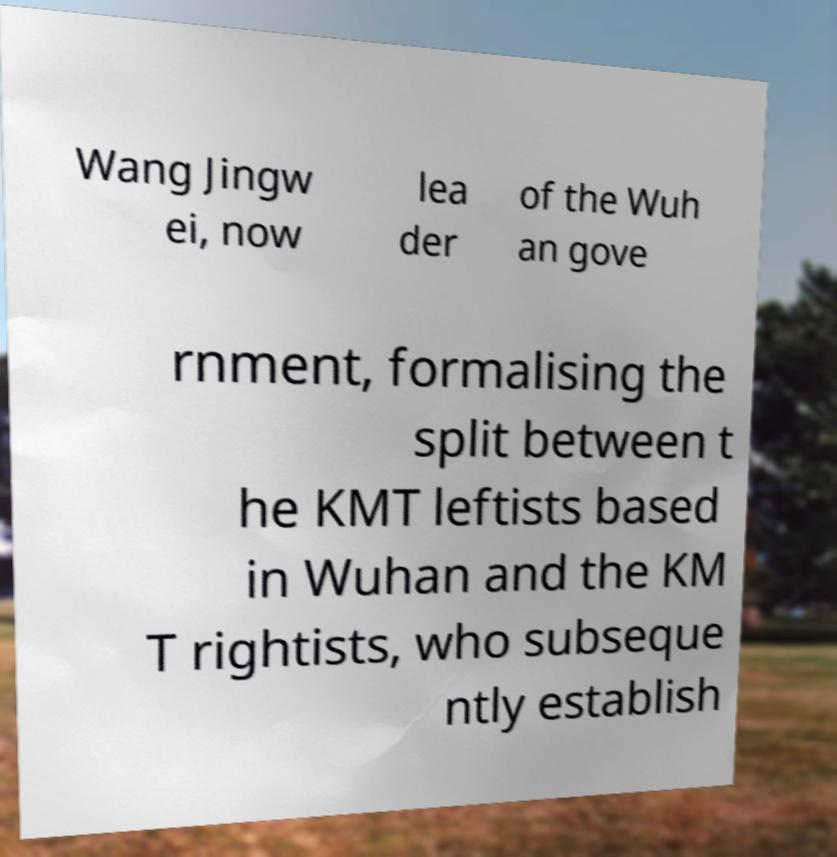What messages or text are displayed in this image? I need them in a readable, typed format. Wang Jingw ei, now lea der of the Wuh an gove rnment, formalising the split between t he KMT leftists based in Wuhan and the KM T rightists, who subseque ntly establish 